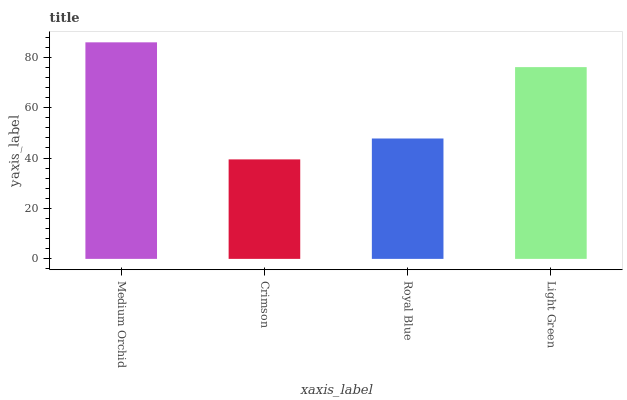Is Crimson the minimum?
Answer yes or no. Yes. Is Medium Orchid the maximum?
Answer yes or no. Yes. Is Royal Blue the minimum?
Answer yes or no. No. Is Royal Blue the maximum?
Answer yes or no. No. Is Royal Blue greater than Crimson?
Answer yes or no. Yes. Is Crimson less than Royal Blue?
Answer yes or no. Yes. Is Crimson greater than Royal Blue?
Answer yes or no. No. Is Royal Blue less than Crimson?
Answer yes or no. No. Is Light Green the high median?
Answer yes or no. Yes. Is Royal Blue the low median?
Answer yes or no. Yes. Is Crimson the high median?
Answer yes or no. No. Is Crimson the low median?
Answer yes or no. No. 